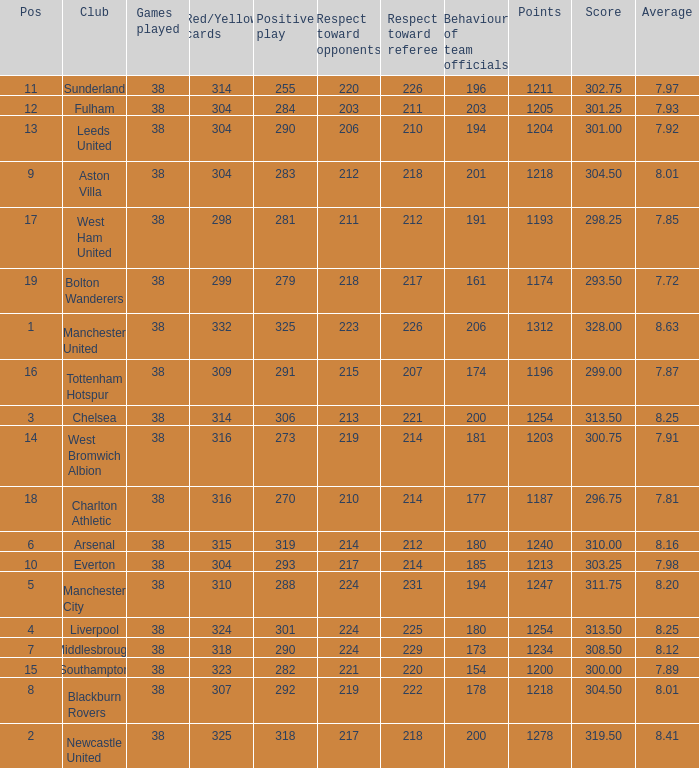Name the points for 212 respect toward opponents 1218.0. 